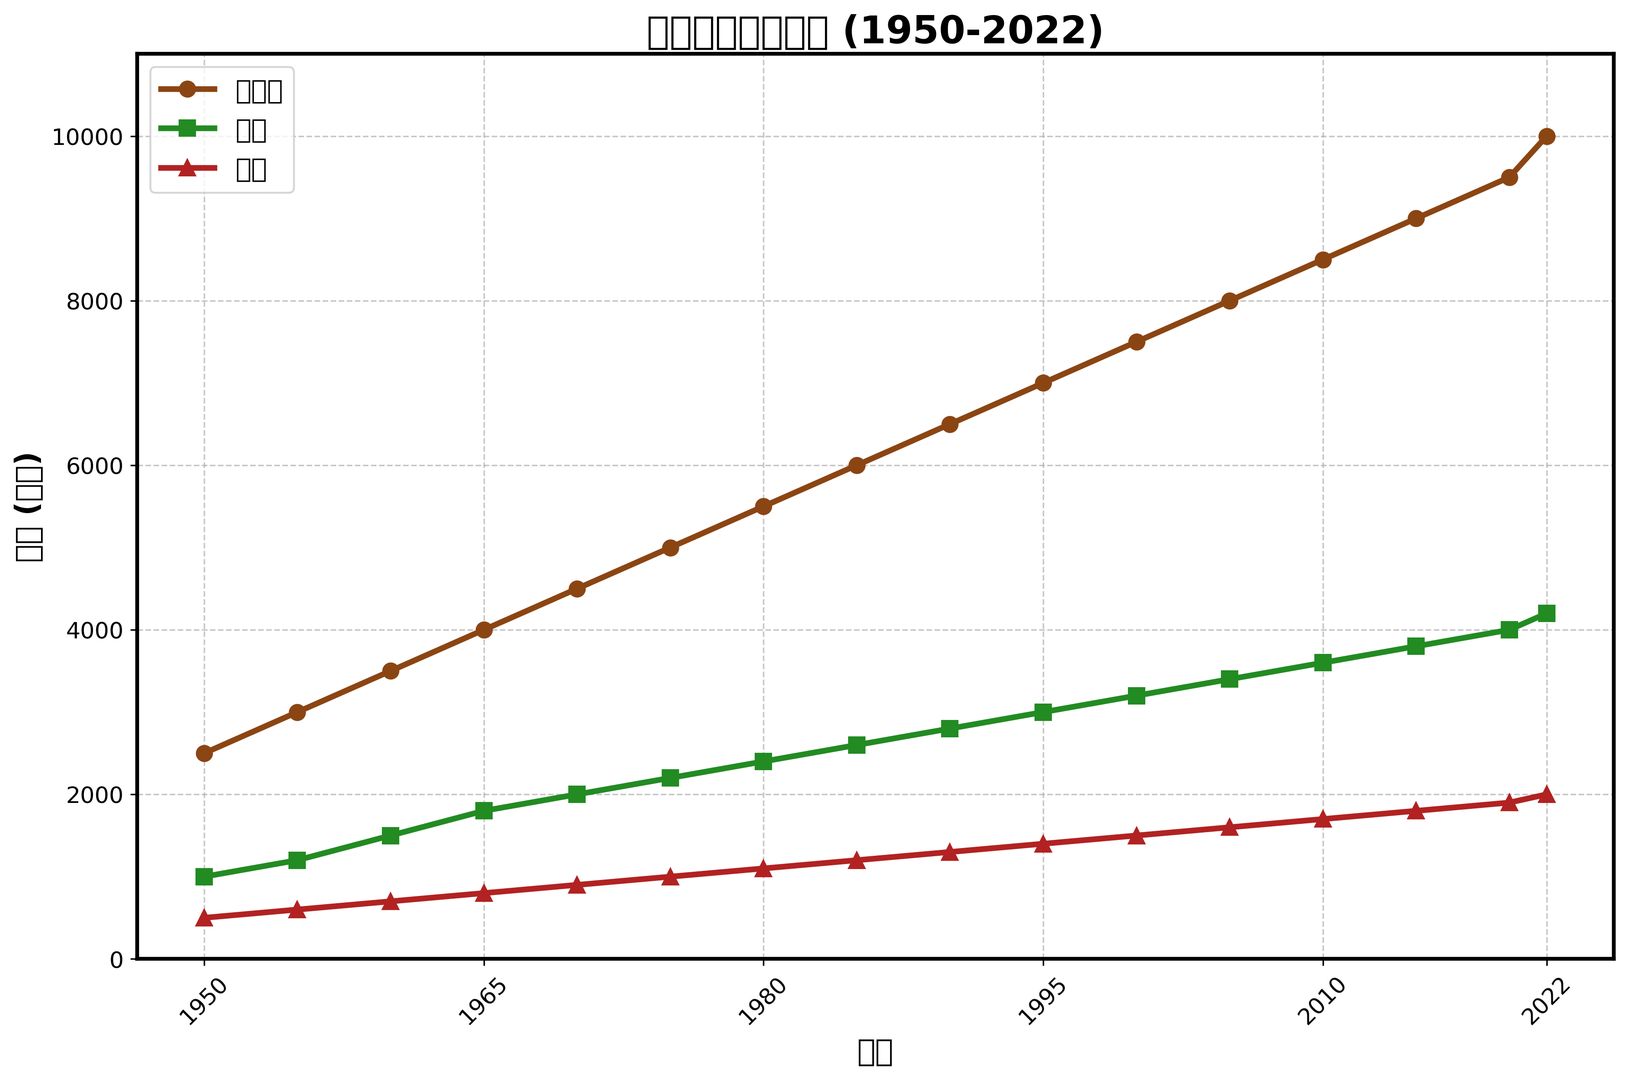What is the production volume of Oolong tea in 2020? Find the value at the point where the year is 2020 on the Oolong tea line.
Answer: 9500 Which type of tea had the highest production volume in 1985? Compare the production volumes of Oolong, Green, and Black tea for 1985; Oolong tea has the highest value.
Answer: Oolong tea By how much did the production of Green tea increase from 1950 to 2022? Subtract the 1950 production volume (1000) from the 2022 production volume (4200) for Green tea.
Answer: 3200 What's the average production volume of Black tea from 1950 to 2022? Add up all the production volumes of Black tea from 1950 to 2022 and divide by the number of data points (16). Calculation: (500 + 600 + 700 + ... + 2000) = 24000 / 16 = 1500.
Answer: 1500 In what year did Oolong tea production surpass 5000 metric tons? Look for the first year where the value of Oolong tea production exceeds 5000 metric tons; this occurs in 1975.
Answer: 1975 Which tea type had the smallest increase in production from 1950 to 2000? Calculate the increase for Oolong (7500-2500), Green (3200-1000), and Black (1500-500). Oolong increased by 5000, Green by 2200, and Black by 1000.
Answer: Black tea Compare the trends for Green tea and Black tea from 1970 to 2020. What do you observe? Observe that both Green tea and Black tea have a steady increase; however, Green tea's increase is more substantial than Black tea's.
Answer: Green tea increased more Between 1960 and 1975, which tea type had the fastest production growth? Calculate the growth for Oolong (5000-3500), Green (2200-1500), and Black (1000-700) in this period. Oolong increased by 1500, Green by 700, and Black by 300.
Answer: Oolong tea What is the relative proportion of Black tea production compared to Green tea in the year 2005? Divide the production of Black tea (1600) by the production of Green tea (3400) in 2005. 1600/3400 gives approximately 0.47.
Answer: 0.47 How did the production volume of Oolong tea change from 1990 to 2015? Subtract the 1990 production volume (6500) from the 2015 production volume (9000) for Oolong tea.
Answer: 2500 